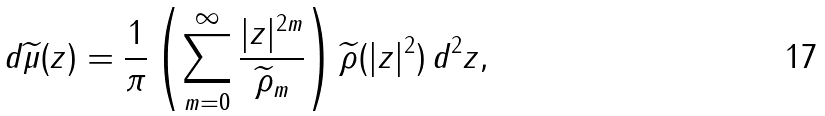<formula> <loc_0><loc_0><loc_500><loc_500>d \widetilde { \mu } ( z ) = \frac { 1 } { \pi } \left ( \sum _ { m = 0 } ^ { \infty } \frac { | z | ^ { 2 m } } { \widetilde { \rho } _ { m } } \right ) \widetilde { \rho } ( | z | ^ { 2 } ) \, d ^ { 2 } z ,</formula> 